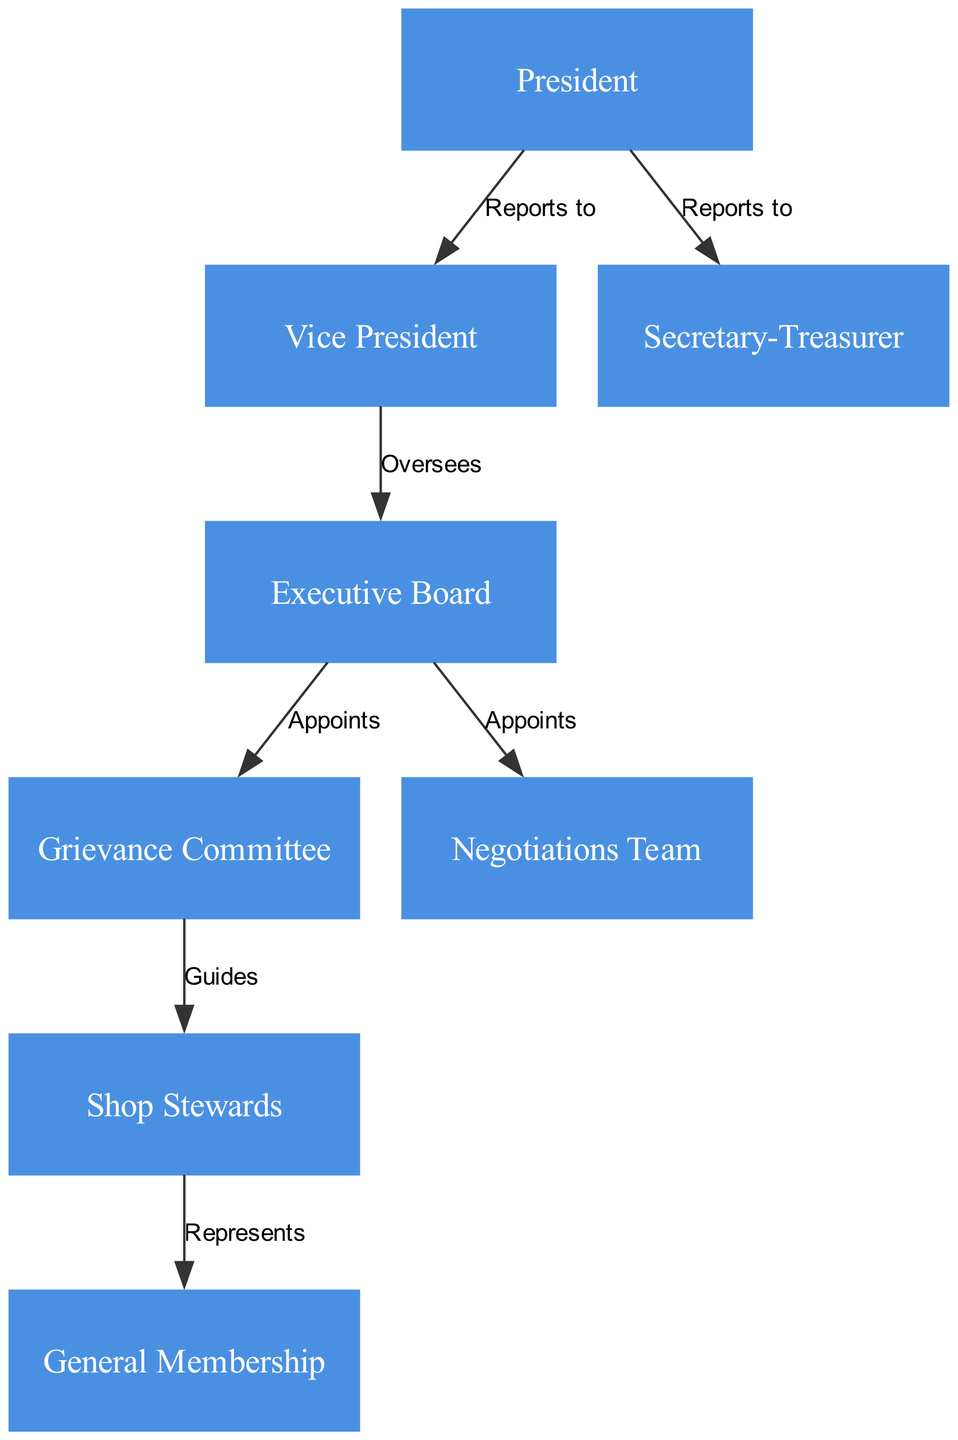What is the highest position in the organizational chart? The highest position in the chart is distinguished by being on level 1. According to the elements of the diagram, the node labeled "President" is placed at this highest level.
Answer: President How many members are part of the Executive Board? The Executive Board is a specific node in the chart. There is only one node labeled "Executive Board" shown, thus signifying a single member of this level in the diagram.
Answer: 1 Who oversees the Executive Board? According to the edges in the diagram, the "Vice President" has a direct connection labeled "Oversees" pointing to the "Executive Board". Hence, the Vice President is the overseeing individual.
Answer: Vice President Which committee guides the Shop Stewards? The edges in the diagram indicate that the "Grievance Committee" has a guiding relationship with the "Shop Stewards". The directional flow shows that the Grievance Committee is the entity guiding the Shop Stewards.
Answer: Grievance Committee What is the relationship between the General Membership and Shop Stewards? The edge labeled "Represents" connects "Shop Stewards" to "General Membership". This indicates that the Shop Stewards act in a representative capacity toward the General Membership.
Answer: Represents How many committees are appointed by the Executive Board? The diagram shows two committees connected to the Executive Board via edges labeled "Appoints": the "Grievance Committee" and the "Negotiations Team". Therefore, there are two committees in total.
Answer: 2 What level do the General Membership members belong to? "General Membership" is specifically identified as being at level 6 in the organizational hierarchy displayed in the diagram. Thus, the answer corresponds directly to that level.
Answer: 6 Who reports directly to the President? The edges from the "President" show that both the "Vice President" and the "Secretary-Treasurer" report directly to this role. This indicates that there are two individuals tied to the President's leadership.
Answer: Vice President, Secretary-Treasurer Which role in the union structure is responsible for negotiations? The diagram specifies that the "Negotiations Team" is appointed by the "Executive Board". Therefore, the Negotiations Team can be identified as the specific role responsible for negotiations.
Answer: Negotiations Team 